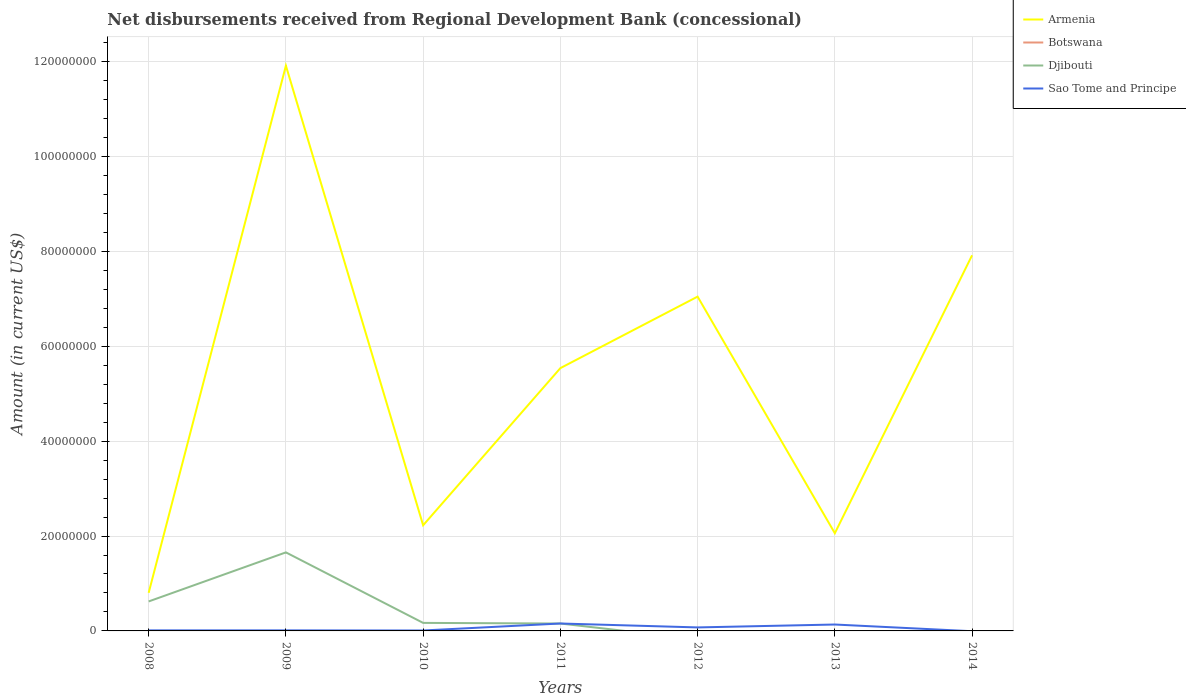Does the line corresponding to Djibouti intersect with the line corresponding to Sao Tome and Principe?
Ensure brevity in your answer.  Yes. Across all years, what is the maximum amount of disbursements received from Regional Development Bank in Sao Tome and Principe?
Ensure brevity in your answer.  0. What is the total amount of disbursements received from Regional Development Bank in Armenia in the graph?
Offer a very short reply. -7.11e+07. What is the difference between the highest and the second highest amount of disbursements received from Regional Development Bank in Djibouti?
Provide a succinct answer. 1.66e+07. What is the difference between the highest and the lowest amount of disbursements received from Regional Development Bank in Botswana?
Make the answer very short. 0. Is the amount of disbursements received from Regional Development Bank in Armenia strictly greater than the amount of disbursements received from Regional Development Bank in Djibouti over the years?
Give a very brief answer. No. How many lines are there?
Offer a very short reply. 3. What is the difference between two consecutive major ticks on the Y-axis?
Provide a short and direct response. 2.00e+07. Does the graph contain any zero values?
Your response must be concise. Yes. Does the graph contain grids?
Give a very brief answer. Yes. What is the title of the graph?
Give a very brief answer. Net disbursements received from Regional Development Bank (concessional). What is the Amount (in current US$) in Armenia in 2008?
Your answer should be very brief. 8.03e+06. What is the Amount (in current US$) in Djibouti in 2008?
Make the answer very short. 6.21e+06. What is the Amount (in current US$) of Sao Tome and Principe in 2008?
Give a very brief answer. 1.18e+05. What is the Amount (in current US$) of Armenia in 2009?
Offer a terse response. 1.19e+08. What is the Amount (in current US$) in Botswana in 2009?
Your answer should be compact. 0. What is the Amount (in current US$) of Djibouti in 2009?
Provide a succinct answer. 1.66e+07. What is the Amount (in current US$) in Armenia in 2010?
Give a very brief answer. 2.23e+07. What is the Amount (in current US$) in Djibouti in 2010?
Provide a short and direct response. 1.69e+06. What is the Amount (in current US$) of Sao Tome and Principe in 2010?
Provide a short and direct response. 9.30e+04. What is the Amount (in current US$) in Armenia in 2011?
Offer a very short reply. 5.54e+07. What is the Amount (in current US$) of Botswana in 2011?
Offer a terse response. 0. What is the Amount (in current US$) of Djibouti in 2011?
Offer a very short reply. 1.56e+06. What is the Amount (in current US$) in Sao Tome and Principe in 2011?
Your answer should be very brief. 1.56e+06. What is the Amount (in current US$) of Armenia in 2012?
Your answer should be compact. 7.05e+07. What is the Amount (in current US$) of Djibouti in 2012?
Your answer should be very brief. 0. What is the Amount (in current US$) in Sao Tome and Principe in 2012?
Offer a very short reply. 7.36e+05. What is the Amount (in current US$) of Armenia in 2013?
Provide a short and direct response. 2.06e+07. What is the Amount (in current US$) of Sao Tome and Principe in 2013?
Ensure brevity in your answer.  1.35e+06. What is the Amount (in current US$) of Armenia in 2014?
Make the answer very short. 7.92e+07. What is the Amount (in current US$) of Djibouti in 2014?
Provide a short and direct response. 0. What is the Amount (in current US$) in Sao Tome and Principe in 2014?
Keep it short and to the point. 0. Across all years, what is the maximum Amount (in current US$) of Armenia?
Provide a short and direct response. 1.19e+08. Across all years, what is the maximum Amount (in current US$) of Djibouti?
Give a very brief answer. 1.66e+07. Across all years, what is the maximum Amount (in current US$) of Sao Tome and Principe?
Provide a succinct answer. 1.56e+06. Across all years, what is the minimum Amount (in current US$) in Armenia?
Your answer should be very brief. 8.03e+06. Across all years, what is the minimum Amount (in current US$) in Djibouti?
Give a very brief answer. 0. Across all years, what is the minimum Amount (in current US$) in Sao Tome and Principe?
Provide a short and direct response. 0. What is the total Amount (in current US$) of Armenia in the graph?
Make the answer very short. 3.75e+08. What is the total Amount (in current US$) of Botswana in the graph?
Give a very brief answer. 0. What is the total Amount (in current US$) of Djibouti in the graph?
Provide a short and direct response. 2.60e+07. What is the total Amount (in current US$) in Sao Tome and Principe in the graph?
Make the answer very short. 3.98e+06. What is the difference between the Amount (in current US$) of Armenia in 2008 and that in 2009?
Ensure brevity in your answer.  -1.11e+08. What is the difference between the Amount (in current US$) in Djibouti in 2008 and that in 2009?
Your response must be concise. -1.03e+07. What is the difference between the Amount (in current US$) in Sao Tome and Principe in 2008 and that in 2009?
Provide a succinct answer. -2000. What is the difference between the Amount (in current US$) in Armenia in 2008 and that in 2010?
Your response must be concise. -1.42e+07. What is the difference between the Amount (in current US$) in Djibouti in 2008 and that in 2010?
Provide a short and direct response. 4.52e+06. What is the difference between the Amount (in current US$) in Sao Tome and Principe in 2008 and that in 2010?
Offer a terse response. 2.50e+04. What is the difference between the Amount (in current US$) of Armenia in 2008 and that in 2011?
Give a very brief answer. -4.74e+07. What is the difference between the Amount (in current US$) of Djibouti in 2008 and that in 2011?
Give a very brief answer. 4.65e+06. What is the difference between the Amount (in current US$) in Sao Tome and Principe in 2008 and that in 2011?
Offer a very short reply. -1.44e+06. What is the difference between the Amount (in current US$) of Armenia in 2008 and that in 2012?
Give a very brief answer. -6.24e+07. What is the difference between the Amount (in current US$) of Sao Tome and Principe in 2008 and that in 2012?
Your response must be concise. -6.18e+05. What is the difference between the Amount (in current US$) of Armenia in 2008 and that in 2013?
Your answer should be very brief. -1.26e+07. What is the difference between the Amount (in current US$) of Sao Tome and Principe in 2008 and that in 2013?
Your answer should be very brief. -1.23e+06. What is the difference between the Amount (in current US$) in Armenia in 2008 and that in 2014?
Your answer should be very brief. -7.11e+07. What is the difference between the Amount (in current US$) in Armenia in 2009 and that in 2010?
Offer a very short reply. 9.69e+07. What is the difference between the Amount (in current US$) in Djibouti in 2009 and that in 2010?
Offer a very short reply. 1.49e+07. What is the difference between the Amount (in current US$) in Sao Tome and Principe in 2009 and that in 2010?
Your response must be concise. 2.70e+04. What is the difference between the Amount (in current US$) of Armenia in 2009 and that in 2011?
Your answer should be compact. 6.37e+07. What is the difference between the Amount (in current US$) in Djibouti in 2009 and that in 2011?
Your response must be concise. 1.50e+07. What is the difference between the Amount (in current US$) of Sao Tome and Principe in 2009 and that in 2011?
Offer a very short reply. -1.44e+06. What is the difference between the Amount (in current US$) of Armenia in 2009 and that in 2012?
Give a very brief answer. 4.87e+07. What is the difference between the Amount (in current US$) of Sao Tome and Principe in 2009 and that in 2012?
Provide a short and direct response. -6.16e+05. What is the difference between the Amount (in current US$) in Armenia in 2009 and that in 2013?
Ensure brevity in your answer.  9.85e+07. What is the difference between the Amount (in current US$) in Sao Tome and Principe in 2009 and that in 2013?
Keep it short and to the point. -1.23e+06. What is the difference between the Amount (in current US$) of Armenia in 2009 and that in 2014?
Keep it short and to the point. 4.00e+07. What is the difference between the Amount (in current US$) in Armenia in 2010 and that in 2011?
Your answer should be very brief. -3.31e+07. What is the difference between the Amount (in current US$) in Djibouti in 2010 and that in 2011?
Make the answer very short. 1.32e+05. What is the difference between the Amount (in current US$) of Sao Tome and Principe in 2010 and that in 2011?
Offer a very short reply. -1.47e+06. What is the difference between the Amount (in current US$) of Armenia in 2010 and that in 2012?
Your response must be concise. -4.82e+07. What is the difference between the Amount (in current US$) in Sao Tome and Principe in 2010 and that in 2012?
Provide a succinct answer. -6.43e+05. What is the difference between the Amount (in current US$) of Armenia in 2010 and that in 2013?
Give a very brief answer. 1.67e+06. What is the difference between the Amount (in current US$) in Sao Tome and Principe in 2010 and that in 2013?
Keep it short and to the point. -1.26e+06. What is the difference between the Amount (in current US$) in Armenia in 2010 and that in 2014?
Offer a terse response. -5.69e+07. What is the difference between the Amount (in current US$) in Armenia in 2011 and that in 2012?
Offer a very short reply. -1.51e+07. What is the difference between the Amount (in current US$) in Sao Tome and Principe in 2011 and that in 2012?
Offer a terse response. 8.27e+05. What is the difference between the Amount (in current US$) in Armenia in 2011 and that in 2013?
Make the answer very short. 3.48e+07. What is the difference between the Amount (in current US$) in Sao Tome and Principe in 2011 and that in 2013?
Make the answer very short. 2.13e+05. What is the difference between the Amount (in current US$) of Armenia in 2011 and that in 2014?
Your answer should be very brief. -2.38e+07. What is the difference between the Amount (in current US$) of Armenia in 2012 and that in 2013?
Ensure brevity in your answer.  4.99e+07. What is the difference between the Amount (in current US$) in Sao Tome and Principe in 2012 and that in 2013?
Ensure brevity in your answer.  -6.14e+05. What is the difference between the Amount (in current US$) of Armenia in 2012 and that in 2014?
Ensure brevity in your answer.  -8.71e+06. What is the difference between the Amount (in current US$) of Armenia in 2013 and that in 2014?
Make the answer very short. -5.86e+07. What is the difference between the Amount (in current US$) in Armenia in 2008 and the Amount (in current US$) in Djibouti in 2009?
Give a very brief answer. -8.52e+06. What is the difference between the Amount (in current US$) in Armenia in 2008 and the Amount (in current US$) in Sao Tome and Principe in 2009?
Your answer should be compact. 7.91e+06. What is the difference between the Amount (in current US$) of Djibouti in 2008 and the Amount (in current US$) of Sao Tome and Principe in 2009?
Your response must be concise. 6.09e+06. What is the difference between the Amount (in current US$) of Armenia in 2008 and the Amount (in current US$) of Djibouti in 2010?
Make the answer very short. 6.34e+06. What is the difference between the Amount (in current US$) of Armenia in 2008 and the Amount (in current US$) of Sao Tome and Principe in 2010?
Your answer should be very brief. 7.94e+06. What is the difference between the Amount (in current US$) of Djibouti in 2008 and the Amount (in current US$) of Sao Tome and Principe in 2010?
Provide a succinct answer. 6.12e+06. What is the difference between the Amount (in current US$) in Armenia in 2008 and the Amount (in current US$) in Djibouti in 2011?
Your answer should be compact. 6.47e+06. What is the difference between the Amount (in current US$) of Armenia in 2008 and the Amount (in current US$) of Sao Tome and Principe in 2011?
Offer a very short reply. 6.47e+06. What is the difference between the Amount (in current US$) of Djibouti in 2008 and the Amount (in current US$) of Sao Tome and Principe in 2011?
Give a very brief answer. 4.65e+06. What is the difference between the Amount (in current US$) of Armenia in 2008 and the Amount (in current US$) of Sao Tome and Principe in 2012?
Provide a short and direct response. 7.30e+06. What is the difference between the Amount (in current US$) in Djibouti in 2008 and the Amount (in current US$) in Sao Tome and Principe in 2012?
Provide a short and direct response. 5.48e+06. What is the difference between the Amount (in current US$) of Armenia in 2008 and the Amount (in current US$) of Sao Tome and Principe in 2013?
Your response must be concise. 6.68e+06. What is the difference between the Amount (in current US$) in Djibouti in 2008 and the Amount (in current US$) in Sao Tome and Principe in 2013?
Keep it short and to the point. 4.86e+06. What is the difference between the Amount (in current US$) of Armenia in 2009 and the Amount (in current US$) of Djibouti in 2010?
Provide a short and direct response. 1.17e+08. What is the difference between the Amount (in current US$) in Armenia in 2009 and the Amount (in current US$) in Sao Tome and Principe in 2010?
Offer a terse response. 1.19e+08. What is the difference between the Amount (in current US$) of Djibouti in 2009 and the Amount (in current US$) of Sao Tome and Principe in 2010?
Provide a short and direct response. 1.65e+07. What is the difference between the Amount (in current US$) of Armenia in 2009 and the Amount (in current US$) of Djibouti in 2011?
Make the answer very short. 1.18e+08. What is the difference between the Amount (in current US$) in Armenia in 2009 and the Amount (in current US$) in Sao Tome and Principe in 2011?
Your answer should be very brief. 1.18e+08. What is the difference between the Amount (in current US$) in Djibouti in 2009 and the Amount (in current US$) in Sao Tome and Principe in 2011?
Provide a succinct answer. 1.50e+07. What is the difference between the Amount (in current US$) in Armenia in 2009 and the Amount (in current US$) in Sao Tome and Principe in 2012?
Offer a very short reply. 1.18e+08. What is the difference between the Amount (in current US$) of Djibouti in 2009 and the Amount (in current US$) of Sao Tome and Principe in 2012?
Your answer should be compact. 1.58e+07. What is the difference between the Amount (in current US$) of Armenia in 2009 and the Amount (in current US$) of Sao Tome and Principe in 2013?
Make the answer very short. 1.18e+08. What is the difference between the Amount (in current US$) in Djibouti in 2009 and the Amount (in current US$) in Sao Tome and Principe in 2013?
Offer a terse response. 1.52e+07. What is the difference between the Amount (in current US$) of Armenia in 2010 and the Amount (in current US$) of Djibouti in 2011?
Give a very brief answer. 2.07e+07. What is the difference between the Amount (in current US$) of Armenia in 2010 and the Amount (in current US$) of Sao Tome and Principe in 2011?
Ensure brevity in your answer.  2.07e+07. What is the difference between the Amount (in current US$) of Armenia in 2010 and the Amount (in current US$) of Sao Tome and Principe in 2012?
Provide a short and direct response. 2.15e+07. What is the difference between the Amount (in current US$) in Djibouti in 2010 and the Amount (in current US$) in Sao Tome and Principe in 2012?
Your answer should be compact. 9.57e+05. What is the difference between the Amount (in current US$) of Armenia in 2010 and the Amount (in current US$) of Sao Tome and Principe in 2013?
Offer a very short reply. 2.09e+07. What is the difference between the Amount (in current US$) of Djibouti in 2010 and the Amount (in current US$) of Sao Tome and Principe in 2013?
Give a very brief answer. 3.43e+05. What is the difference between the Amount (in current US$) in Armenia in 2011 and the Amount (in current US$) in Sao Tome and Principe in 2012?
Offer a terse response. 5.47e+07. What is the difference between the Amount (in current US$) of Djibouti in 2011 and the Amount (in current US$) of Sao Tome and Principe in 2012?
Your response must be concise. 8.25e+05. What is the difference between the Amount (in current US$) of Armenia in 2011 and the Amount (in current US$) of Sao Tome and Principe in 2013?
Your answer should be compact. 5.40e+07. What is the difference between the Amount (in current US$) in Djibouti in 2011 and the Amount (in current US$) in Sao Tome and Principe in 2013?
Ensure brevity in your answer.  2.11e+05. What is the difference between the Amount (in current US$) in Armenia in 2012 and the Amount (in current US$) in Sao Tome and Principe in 2013?
Give a very brief answer. 6.91e+07. What is the average Amount (in current US$) in Armenia per year?
Offer a terse response. 5.36e+07. What is the average Amount (in current US$) in Djibouti per year?
Your answer should be compact. 3.72e+06. What is the average Amount (in current US$) in Sao Tome and Principe per year?
Keep it short and to the point. 5.69e+05. In the year 2008, what is the difference between the Amount (in current US$) of Armenia and Amount (in current US$) of Djibouti?
Offer a very short reply. 1.82e+06. In the year 2008, what is the difference between the Amount (in current US$) of Armenia and Amount (in current US$) of Sao Tome and Principe?
Provide a short and direct response. 7.91e+06. In the year 2008, what is the difference between the Amount (in current US$) of Djibouti and Amount (in current US$) of Sao Tome and Principe?
Provide a succinct answer. 6.10e+06. In the year 2009, what is the difference between the Amount (in current US$) in Armenia and Amount (in current US$) in Djibouti?
Give a very brief answer. 1.03e+08. In the year 2009, what is the difference between the Amount (in current US$) of Armenia and Amount (in current US$) of Sao Tome and Principe?
Provide a succinct answer. 1.19e+08. In the year 2009, what is the difference between the Amount (in current US$) in Djibouti and Amount (in current US$) in Sao Tome and Principe?
Your answer should be compact. 1.64e+07. In the year 2010, what is the difference between the Amount (in current US$) of Armenia and Amount (in current US$) of Djibouti?
Keep it short and to the point. 2.06e+07. In the year 2010, what is the difference between the Amount (in current US$) in Armenia and Amount (in current US$) in Sao Tome and Principe?
Your answer should be very brief. 2.22e+07. In the year 2010, what is the difference between the Amount (in current US$) in Djibouti and Amount (in current US$) in Sao Tome and Principe?
Offer a very short reply. 1.60e+06. In the year 2011, what is the difference between the Amount (in current US$) of Armenia and Amount (in current US$) of Djibouti?
Provide a succinct answer. 5.38e+07. In the year 2011, what is the difference between the Amount (in current US$) in Armenia and Amount (in current US$) in Sao Tome and Principe?
Your answer should be compact. 5.38e+07. In the year 2011, what is the difference between the Amount (in current US$) of Djibouti and Amount (in current US$) of Sao Tome and Principe?
Offer a terse response. -2000. In the year 2012, what is the difference between the Amount (in current US$) of Armenia and Amount (in current US$) of Sao Tome and Principe?
Keep it short and to the point. 6.97e+07. In the year 2013, what is the difference between the Amount (in current US$) in Armenia and Amount (in current US$) in Sao Tome and Principe?
Keep it short and to the point. 1.92e+07. What is the ratio of the Amount (in current US$) of Armenia in 2008 to that in 2009?
Your response must be concise. 0.07. What is the ratio of the Amount (in current US$) of Djibouti in 2008 to that in 2009?
Your response must be concise. 0.38. What is the ratio of the Amount (in current US$) in Sao Tome and Principe in 2008 to that in 2009?
Provide a short and direct response. 0.98. What is the ratio of the Amount (in current US$) in Armenia in 2008 to that in 2010?
Make the answer very short. 0.36. What is the ratio of the Amount (in current US$) of Djibouti in 2008 to that in 2010?
Your answer should be compact. 3.67. What is the ratio of the Amount (in current US$) in Sao Tome and Principe in 2008 to that in 2010?
Keep it short and to the point. 1.27. What is the ratio of the Amount (in current US$) in Armenia in 2008 to that in 2011?
Ensure brevity in your answer.  0.14. What is the ratio of the Amount (in current US$) in Djibouti in 2008 to that in 2011?
Provide a succinct answer. 3.98. What is the ratio of the Amount (in current US$) of Sao Tome and Principe in 2008 to that in 2011?
Give a very brief answer. 0.08. What is the ratio of the Amount (in current US$) of Armenia in 2008 to that in 2012?
Make the answer very short. 0.11. What is the ratio of the Amount (in current US$) of Sao Tome and Principe in 2008 to that in 2012?
Provide a succinct answer. 0.16. What is the ratio of the Amount (in current US$) of Armenia in 2008 to that in 2013?
Give a very brief answer. 0.39. What is the ratio of the Amount (in current US$) of Sao Tome and Principe in 2008 to that in 2013?
Offer a very short reply. 0.09. What is the ratio of the Amount (in current US$) in Armenia in 2008 to that in 2014?
Your response must be concise. 0.1. What is the ratio of the Amount (in current US$) in Armenia in 2009 to that in 2010?
Your answer should be compact. 5.35. What is the ratio of the Amount (in current US$) in Djibouti in 2009 to that in 2010?
Provide a short and direct response. 9.78. What is the ratio of the Amount (in current US$) of Sao Tome and Principe in 2009 to that in 2010?
Provide a succinct answer. 1.29. What is the ratio of the Amount (in current US$) in Armenia in 2009 to that in 2011?
Provide a succinct answer. 2.15. What is the ratio of the Amount (in current US$) in Djibouti in 2009 to that in 2011?
Ensure brevity in your answer.  10.6. What is the ratio of the Amount (in current US$) of Sao Tome and Principe in 2009 to that in 2011?
Offer a terse response. 0.08. What is the ratio of the Amount (in current US$) of Armenia in 2009 to that in 2012?
Your answer should be compact. 1.69. What is the ratio of the Amount (in current US$) of Sao Tome and Principe in 2009 to that in 2012?
Your answer should be very brief. 0.16. What is the ratio of the Amount (in current US$) of Armenia in 2009 to that in 2013?
Your answer should be very brief. 5.79. What is the ratio of the Amount (in current US$) in Sao Tome and Principe in 2009 to that in 2013?
Your response must be concise. 0.09. What is the ratio of the Amount (in current US$) of Armenia in 2009 to that in 2014?
Ensure brevity in your answer.  1.5. What is the ratio of the Amount (in current US$) of Armenia in 2010 to that in 2011?
Your answer should be compact. 0.4. What is the ratio of the Amount (in current US$) in Djibouti in 2010 to that in 2011?
Your answer should be compact. 1.08. What is the ratio of the Amount (in current US$) in Sao Tome and Principe in 2010 to that in 2011?
Offer a terse response. 0.06. What is the ratio of the Amount (in current US$) in Armenia in 2010 to that in 2012?
Your response must be concise. 0.32. What is the ratio of the Amount (in current US$) of Sao Tome and Principe in 2010 to that in 2012?
Your answer should be compact. 0.13. What is the ratio of the Amount (in current US$) of Armenia in 2010 to that in 2013?
Keep it short and to the point. 1.08. What is the ratio of the Amount (in current US$) in Sao Tome and Principe in 2010 to that in 2013?
Your answer should be very brief. 0.07. What is the ratio of the Amount (in current US$) in Armenia in 2010 to that in 2014?
Make the answer very short. 0.28. What is the ratio of the Amount (in current US$) in Armenia in 2011 to that in 2012?
Provide a succinct answer. 0.79. What is the ratio of the Amount (in current US$) in Sao Tome and Principe in 2011 to that in 2012?
Your response must be concise. 2.12. What is the ratio of the Amount (in current US$) of Armenia in 2011 to that in 2013?
Your answer should be very brief. 2.69. What is the ratio of the Amount (in current US$) of Sao Tome and Principe in 2011 to that in 2013?
Ensure brevity in your answer.  1.16. What is the ratio of the Amount (in current US$) of Armenia in 2011 to that in 2014?
Make the answer very short. 0.7. What is the ratio of the Amount (in current US$) in Armenia in 2012 to that in 2013?
Make the answer very short. 3.42. What is the ratio of the Amount (in current US$) in Sao Tome and Principe in 2012 to that in 2013?
Your answer should be very brief. 0.55. What is the ratio of the Amount (in current US$) of Armenia in 2012 to that in 2014?
Offer a terse response. 0.89. What is the ratio of the Amount (in current US$) of Armenia in 2013 to that in 2014?
Provide a succinct answer. 0.26. What is the difference between the highest and the second highest Amount (in current US$) in Armenia?
Provide a short and direct response. 4.00e+07. What is the difference between the highest and the second highest Amount (in current US$) in Djibouti?
Your answer should be very brief. 1.03e+07. What is the difference between the highest and the second highest Amount (in current US$) in Sao Tome and Principe?
Provide a short and direct response. 2.13e+05. What is the difference between the highest and the lowest Amount (in current US$) of Armenia?
Give a very brief answer. 1.11e+08. What is the difference between the highest and the lowest Amount (in current US$) of Djibouti?
Give a very brief answer. 1.66e+07. What is the difference between the highest and the lowest Amount (in current US$) of Sao Tome and Principe?
Give a very brief answer. 1.56e+06. 